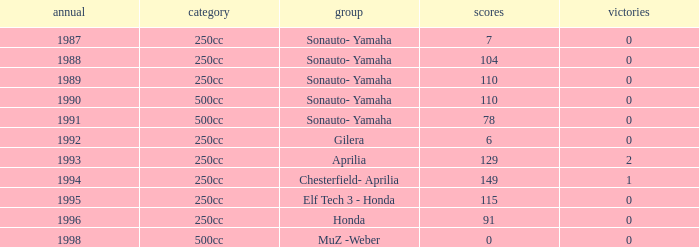How many wins did the team, which had more than 110 points, have in 1989? None. 